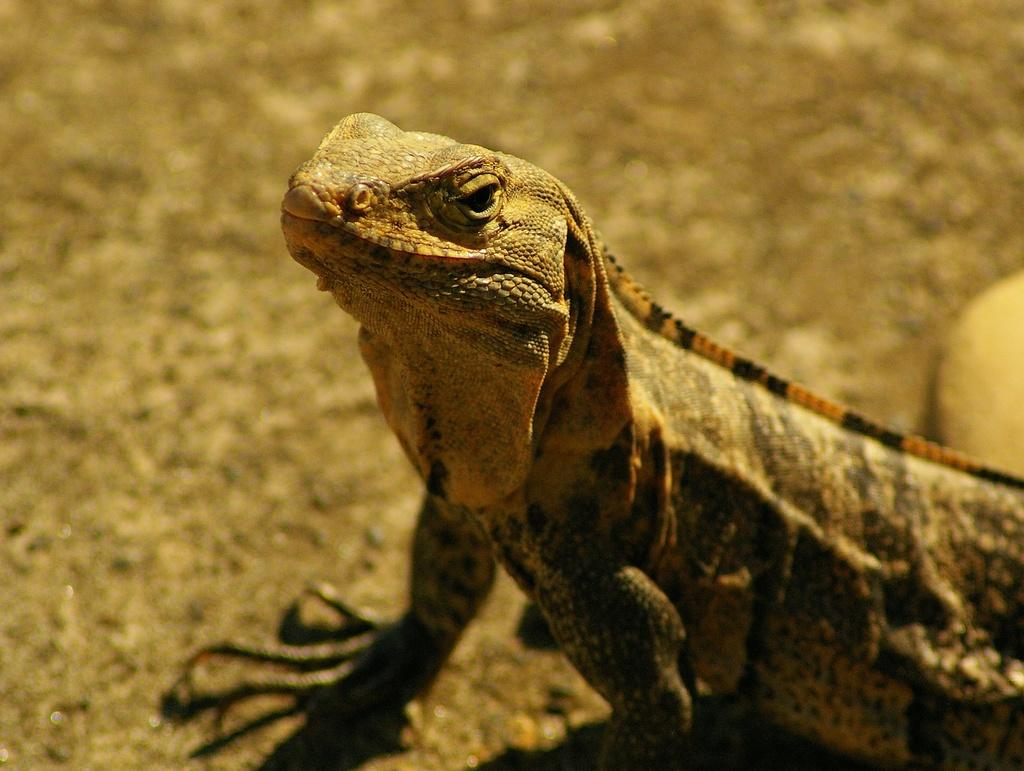What type of animal is in the image? There is a dragon lizard in the image. Where is the dragon lizard located? The dragon lizard is on the floor. What does the dragon lizard's brother do for a living in the image? There is no information about the dragon lizard's brother in the image, as the focus is solely on the dragon lizard itself. 